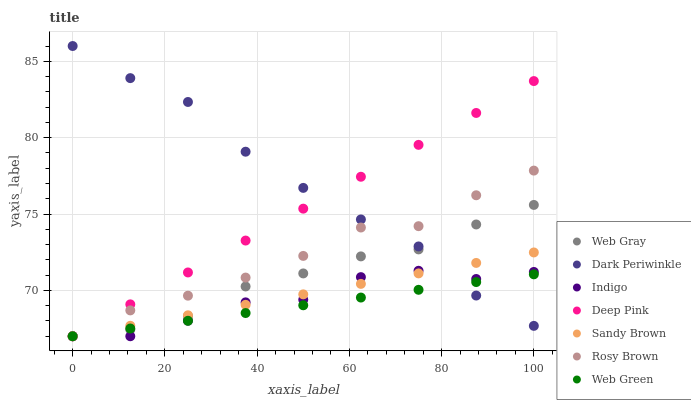Does Web Green have the minimum area under the curve?
Answer yes or no. Yes. Does Dark Periwinkle have the maximum area under the curve?
Answer yes or no. Yes. Does Indigo have the minimum area under the curve?
Answer yes or no. No. Does Indigo have the maximum area under the curve?
Answer yes or no. No. Is Deep Pink the smoothest?
Answer yes or no. Yes. Is Indigo the roughest?
Answer yes or no. Yes. Is Rosy Brown the smoothest?
Answer yes or no. No. Is Rosy Brown the roughest?
Answer yes or no. No. Does Web Gray have the lowest value?
Answer yes or no. Yes. Does Dark Periwinkle have the lowest value?
Answer yes or no. No. Does Dark Periwinkle have the highest value?
Answer yes or no. Yes. Does Indigo have the highest value?
Answer yes or no. No. Does Deep Pink intersect Dark Periwinkle?
Answer yes or no. Yes. Is Deep Pink less than Dark Periwinkle?
Answer yes or no. No. Is Deep Pink greater than Dark Periwinkle?
Answer yes or no. No. 